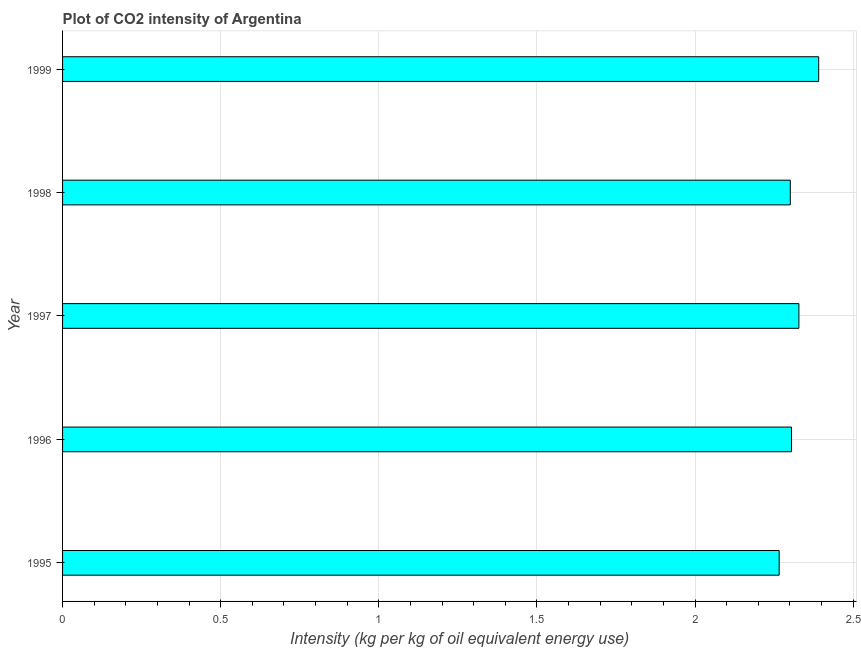Does the graph contain grids?
Keep it short and to the point. Yes. What is the title of the graph?
Offer a terse response. Plot of CO2 intensity of Argentina. What is the label or title of the X-axis?
Offer a very short reply. Intensity (kg per kg of oil equivalent energy use). What is the co2 intensity in 1996?
Ensure brevity in your answer.  2.3. Across all years, what is the maximum co2 intensity?
Provide a succinct answer. 2.39. Across all years, what is the minimum co2 intensity?
Your answer should be very brief. 2.27. In which year was the co2 intensity maximum?
Keep it short and to the point. 1999. What is the sum of the co2 intensity?
Give a very brief answer. 11.59. What is the difference between the co2 intensity in 1998 and 1999?
Provide a short and direct response. -0.09. What is the average co2 intensity per year?
Provide a succinct answer. 2.32. What is the median co2 intensity?
Your answer should be very brief. 2.3. Do a majority of the years between 1999 and 1995 (inclusive) have co2 intensity greater than 0.5 kg?
Offer a terse response. Yes. What is the ratio of the co2 intensity in 1998 to that in 1999?
Make the answer very short. 0.96. Is the co2 intensity in 1995 less than that in 1996?
Make the answer very short. Yes. What is the difference between the highest and the second highest co2 intensity?
Offer a terse response. 0.06. What is the difference between the highest and the lowest co2 intensity?
Keep it short and to the point. 0.12. In how many years, is the co2 intensity greater than the average co2 intensity taken over all years?
Provide a succinct answer. 2. How many bars are there?
Ensure brevity in your answer.  5. Are all the bars in the graph horizontal?
Offer a terse response. Yes. What is the difference between two consecutive major ticks on the X-axis?
Give a very brief answer. 0.5. Are the values on the major ticks of X-axis written in scientific E-notation?
Offer a very short reply. No. What is the Intensity (kg per kg of oil equivalent energy use) in 1995?
Make the answer very short. 2.27. What is the Intensity (kg per kg of oil equivalent energy use) in 1996?
Your response must be concise. 2.3. What is the Intensity (kg per kg of oil equivalent energy use) in 1997?
Ensure brevity in your answer.  2.33. What is the Intensity (kg per kg of oil equivalent energy use) of 1998?
Offer a very short reply. 2.3. What is the Intensity (kg per kg of oil equivalent energy use) of 1999?
Give a very brief answer. 2.39. What is the difference between the Intensity (kg per kg of oil equivalent energy use) in 1995 and 1996?
Give a very brief answer. -0.04. What is the difference between the Intensity (kg per kg of oil equivalent energy use) in 1995 and 1997?
Provide a short and direct response. -0.06. What is the difference between the Intensity (kg per kg of oil equivalent energy use) in 1995 and 1998?
Make the answer very short. -0.04. What is the difference between the Intensity (kg per kg of oil equivalent energy use) in 1995 and 1999?
Make the answer very short. -0.12. What is the difference between the Intensity (kg per kg of oil equivalent energy use) in 1996 and 1997?
Your answer should be compact. -0.02. What is the difference between the Intensity (kg per kg of oil equivalent energy use) in 1996 and 1998?
Ensure brevity in your answer.  0. What is the difference between the Intensity (kg per kg of oil equivalent energy use) in 1996 and 1999?
Provide a succinct answer. -0.09. What is the difference between the Intensity (kg per kg of oil equivalent energy use) in 1997 and 1998?
Your response must be concise. 0.03. What is the difference between the Intensity (kg per kg of oil equivalent energy use) in 1997 and 1999?
Ensure brevity in your answer.  -0.06. What is the difference between the Intensity (kg per kg of oil equivalent energy use) in 1998 and 1999?
Make the answer very short. -0.09. What is the ratio of the Intensity (kg per kg of oil equivalent energy use) in 1995 to that in 1996?
Your response must be concise. 0.98. What is the ratio of the Intensity (kg per kg of oil equivalent energy use) in 1995 to that in 1999?
Keep it short and to the point. 0.95. What is the ratio of the Intensity (kg per kg of oil equivalent energy use) in 1996 to that in 1998?
Your answer should be very brief. 1. What is the ratio of the Intensity (kg per kg of oil equivalent energy use) in 1996 to that in 1999?
Give a very brief answer. 0.96. What is the ratio of the Intensity (kg per kg of oil equivalent energy use) in 1997 to that in 1998?
Offer a very short reply. 1.01. What is the ratio of the Intensity (kg per kg of oil equivalent energy use) in 1998 to that in 1999?
Ensure brevity in your answer.  0.96. 